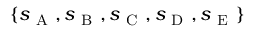<formula> <loc_0><loc_0><loc_500><loc_500>\{ s _ { A } , s _ { B } , s _ { C } , s _ { D } , s _ { E } \}</formula> 